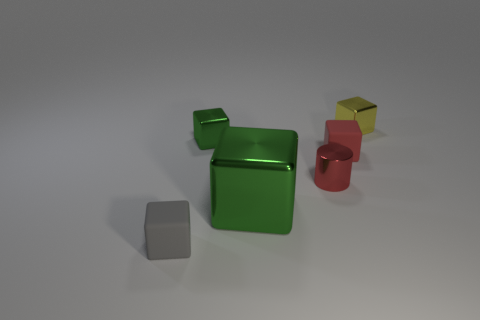How many objects are either blocks that are in front of the large thing or tiny metallic blocks in front of the small yellow cube?
Keep it short and to the point. 2. How many objects are either large red objects or metal cubes?
Keep it short and to the point. 3. What is the size of the metallic thing that is both in front of the yellow thing and to the right of the large green cube?
Your answer should be compact. Small. How many red cylinders have the same material as the large object?
Your answer should be very brief. 1. What color is the tiny cylinder that is the same material as the large object?
Make the answer very short. Red. Do the small thing that is in front of the red metal object and the metallic cylinder have the same color?
Keep it short and to the point. No. What is the green cube on the right side of the small green shiny thing made of?
Your response must be concise. Metal. Are there an equal number of shiny cylinders that are in front of the shiny cylinder and gray metallic cylinders?
Provide a succinct answer. Yes. What number of matte objects have the same color as the cylinder?
Offer a terse response. 1. There is another tiny shiny thing that is the same shape as the yellow thing; what color is it?
Give a very brief answer. Green. 